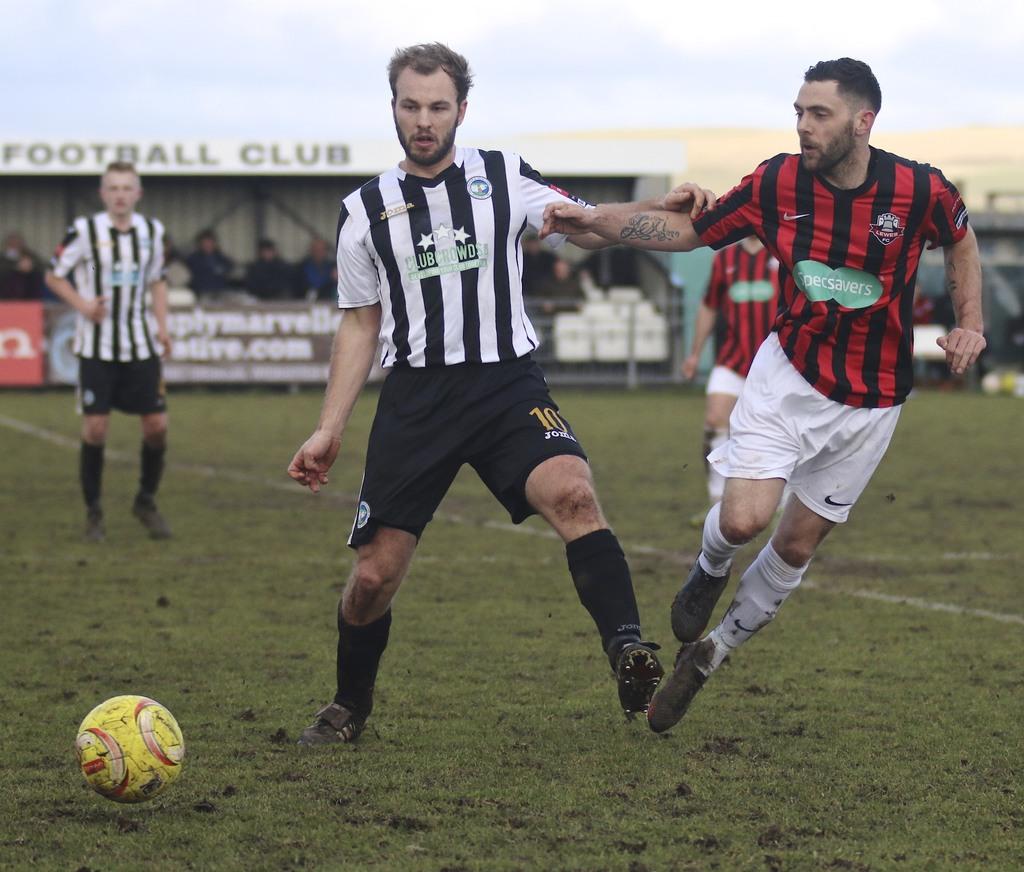What game is being played?
Give a very brief answer. Answering does not require reading text in the image. What does it say behind the players heads?
Your answer should be very brief. Football club. 